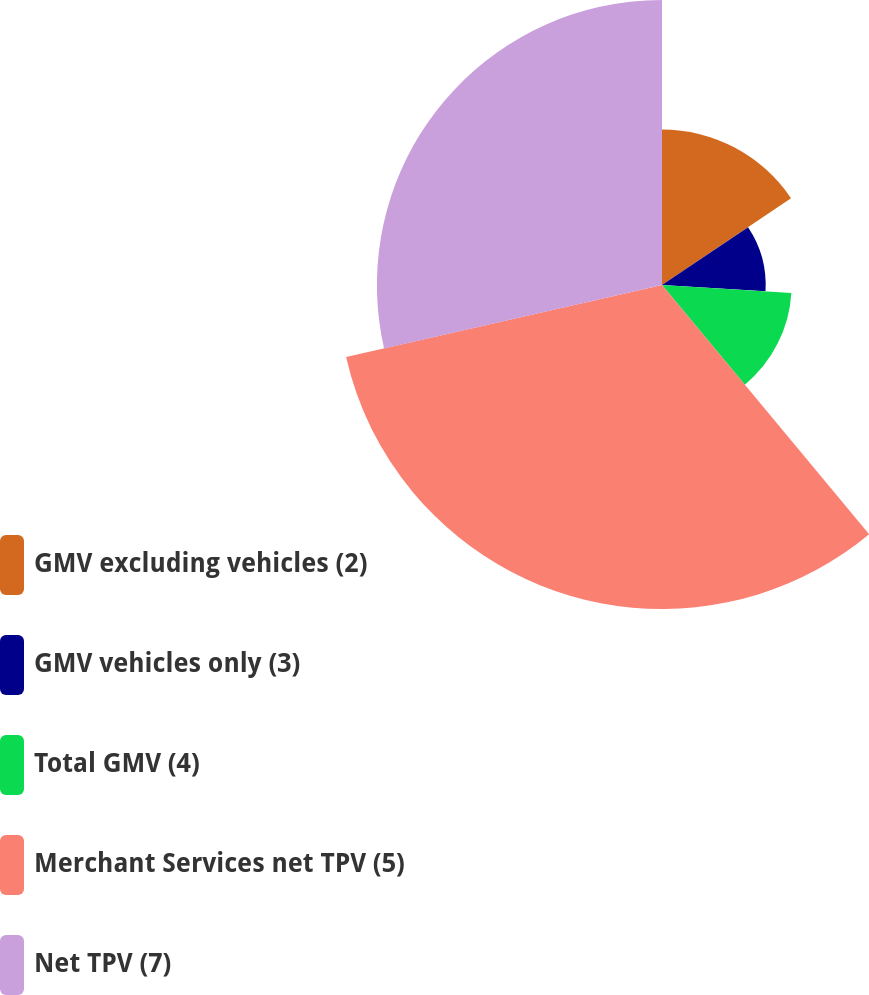Convert chart to OTSL. <chart><loc_0><loc_0><loc_500><loc_500><pie_chart><fcel>GMV excluding vehicles (2)<fcel>GMV vehicles only (3)<fcel>Total GMV (4)<fcel>Merchant Services net TPV (5)<fcel>Net TPV (7)<nl><fcel>15.58%<fcel>10.39%<fcel>12.99%<fcel>32.47%<fcel>28.57%<nl></chart> 